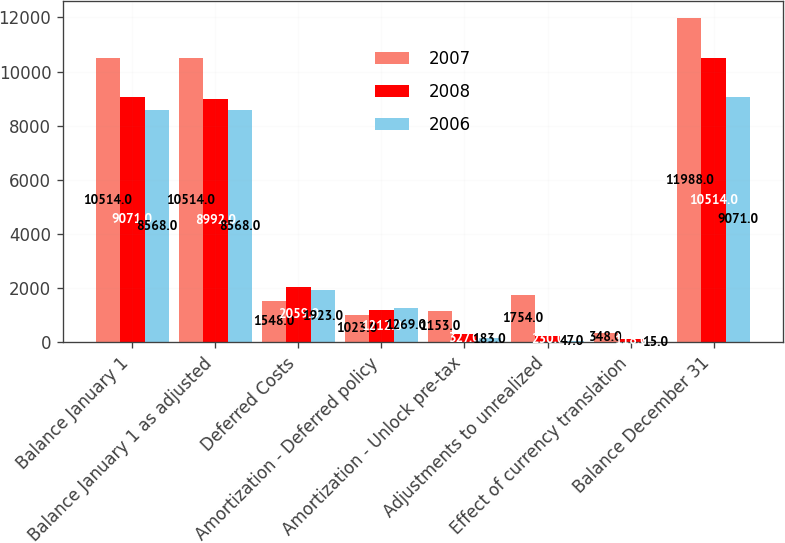Convert chart to OTSL. <chart><loc_0><loc_0><loc_500><loc_500><stacked_bar_chart><ecel><fcel>Balance January 1<fcel>Balance January 1 as adjusted<fcel>Deferred Costs<fcel>Amortization - Deferred policy<fcel>Amortization - Unlock pre-tax<fcel>Adjustments to unrealized<fcel>Effect of currency translation<fcel>Balance December 31<nl><fcel>2007<fcel>10514<fcel>10514<fcel>1548<fcel>1023<fcel>1153<fcel>1754<fcel>348<fcel>11988<nl><fcel>2008<fcel>9071<fcel>8992<fcel>2059<fcel>1212<fcel>327<fcel>230<fcel>118<fcel>10514<nl><fcel>2006<fcel>8568<fcel>8568<fcel>1923<fcel>1269<fcel>183<fcel>47<fcel>15<fcel>9071<nl></chart> 